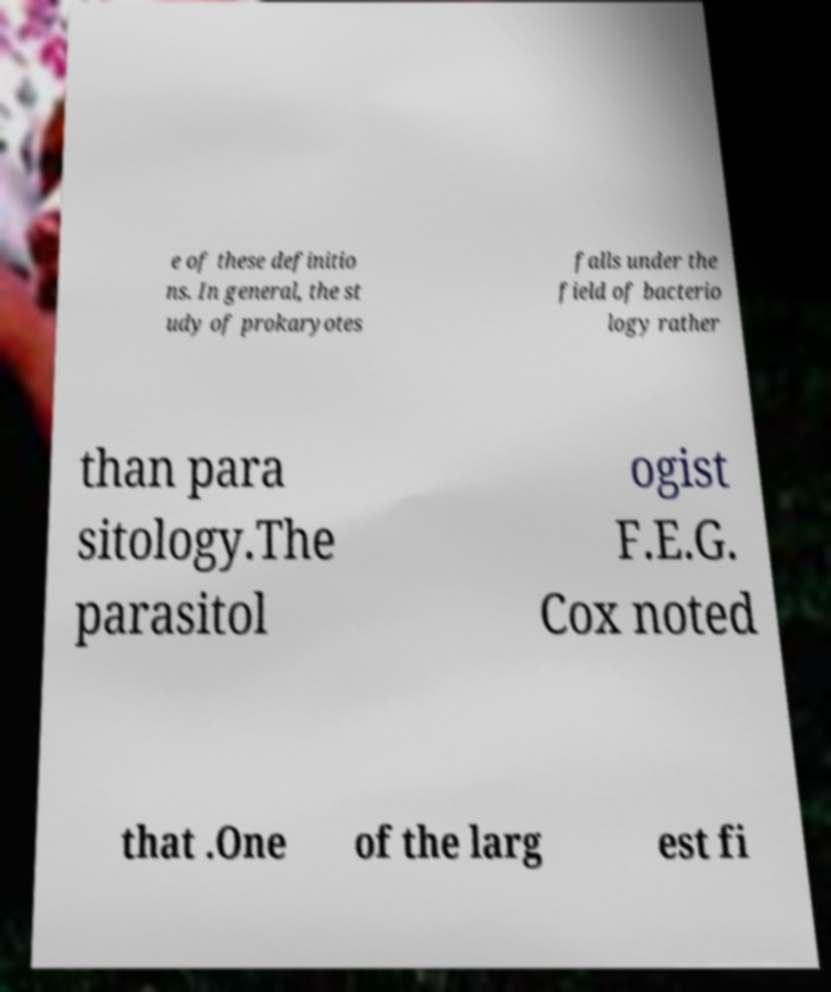Could you assist in decoding the text presented in this image and type it out clearly? e of these definitio ns. In general, the st udy of prokaryotes falls under the field of bacterio logy rather than para sitology.The parasitol ogist F.E.G. Cox noted that .One of the larg est fi 